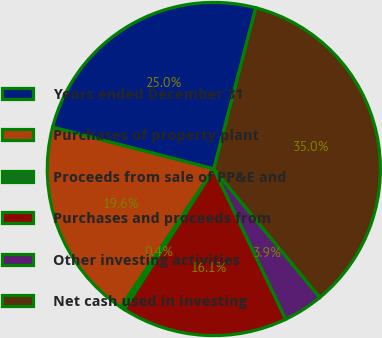Convert chart. <chart><loc_0><loc_0><loc_500><loc_500><pie_chart><fcel>Years ended December 31<fcel>Purchases of property plant<fcel>Proceeds from sale of PP&E and<fcel>Purchases and proceeds from<fcel>Other investing activities<fcel>Net cash used in investing<nl><fcel>25.02%<fcel>19.6%<fcel>0.41%<fcel>16.14%<fcel>3.87%<fcel>34.97%<nl></chart> 